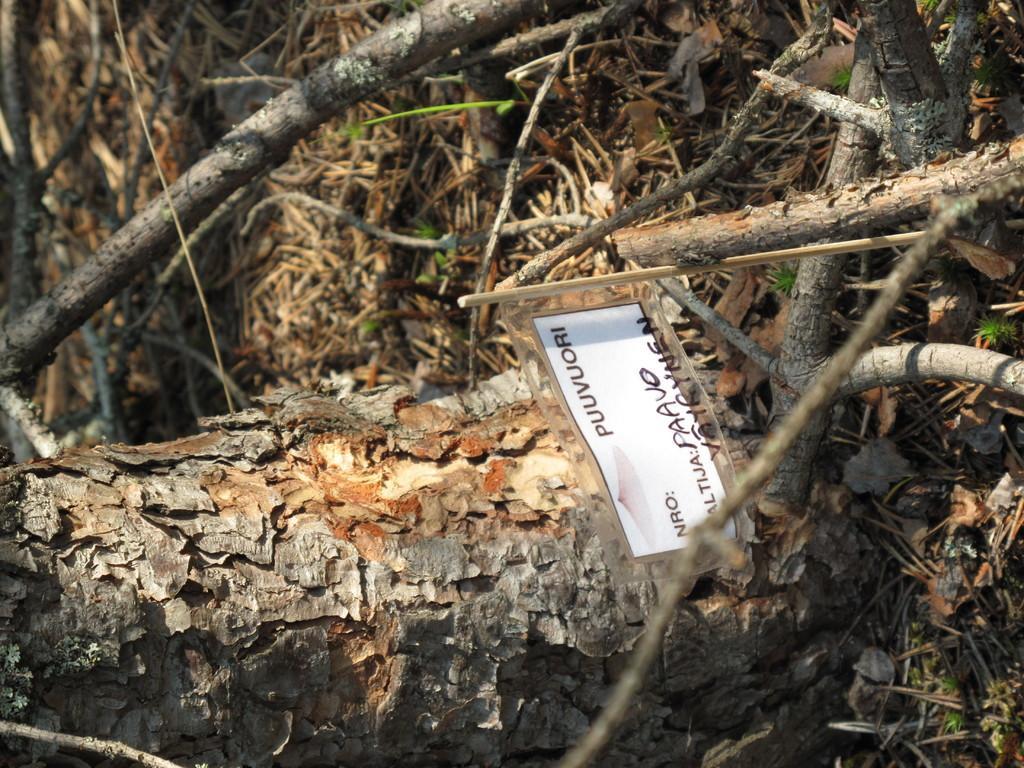Could you give a brief overview of what you see in this image? In this picture we can see a paper attached to the wooden stick and in the background we can see a tree trunk,branches. 